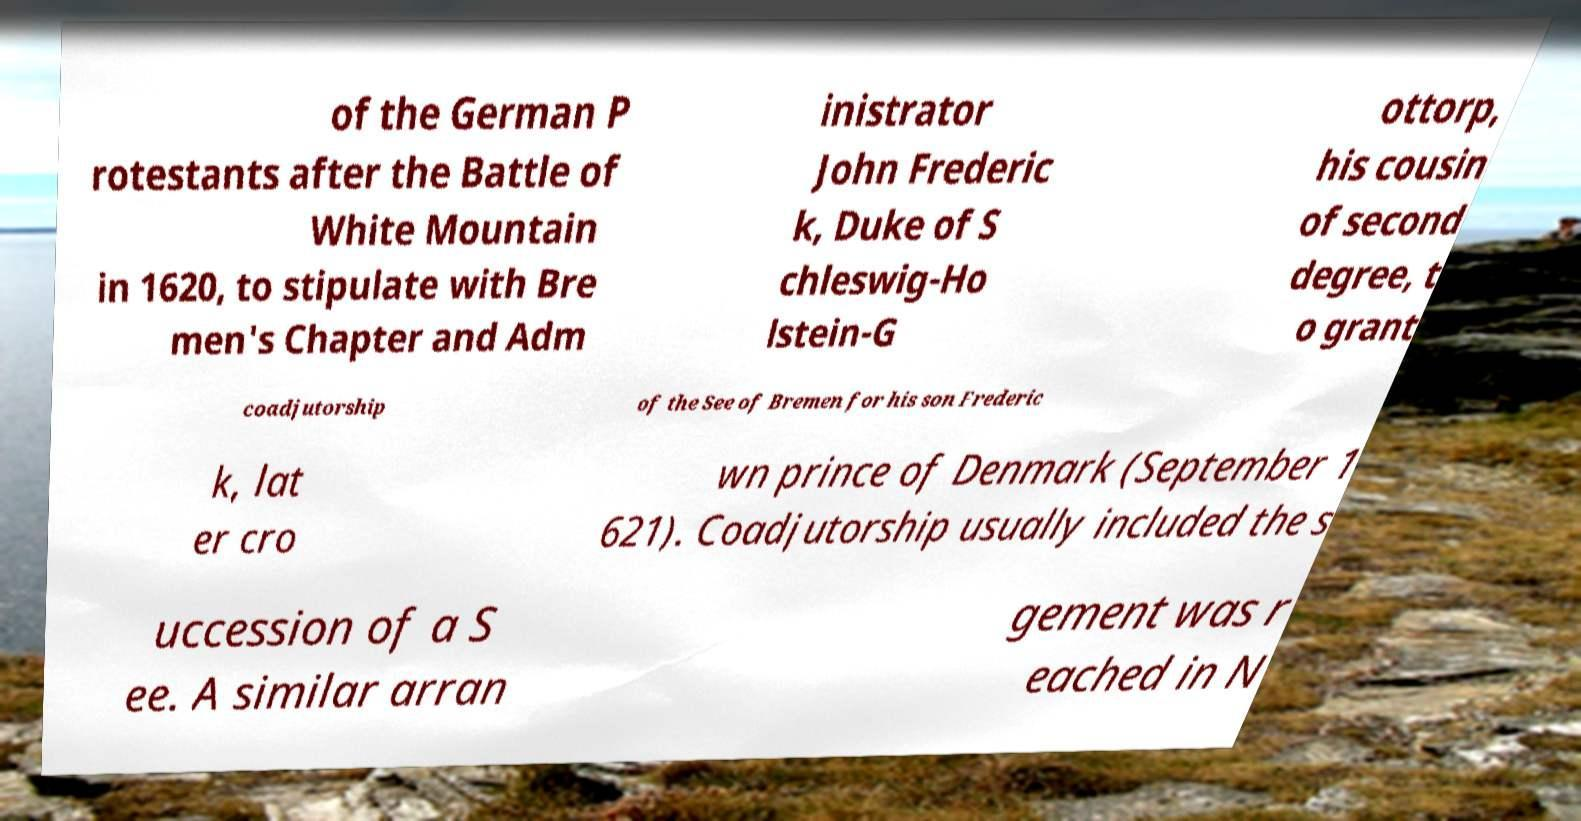I need the written content from this picture converted into text. Can you do that? of the German P rotestants after the Battle of White Mountain in 1620, to stipulate with Bre men's Chapter and Adm inistrator John Frederic k, Duke of S chleswig-Ho lstein-G ottorp, his cousin of second degree, t o grant coadjutorship of the See of Bremen for his son Frederic k, lat er cro wn prince of Denmark (September 1 621). Coadjutorship usually included the s uccession of a S ee. A similar arran gement was r eached in N 